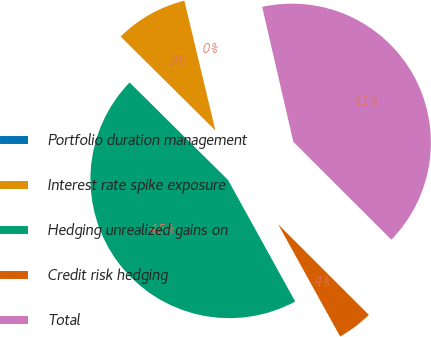Convert chart to OTSL. <chart><loc_0><loc_0><loc_500><loc_500><pie_chart><fcel>Portfolio duration management<fcel>Interest rate spike exposure<fcel>Hedging unrealized gains on<fcel>Credit risk hedging<fcel>Total<nl><fcel>0.13%<fcel>8.83%<fcel>45.46%<fcel>4.48%<fcel>41.1%<nl></chart> 